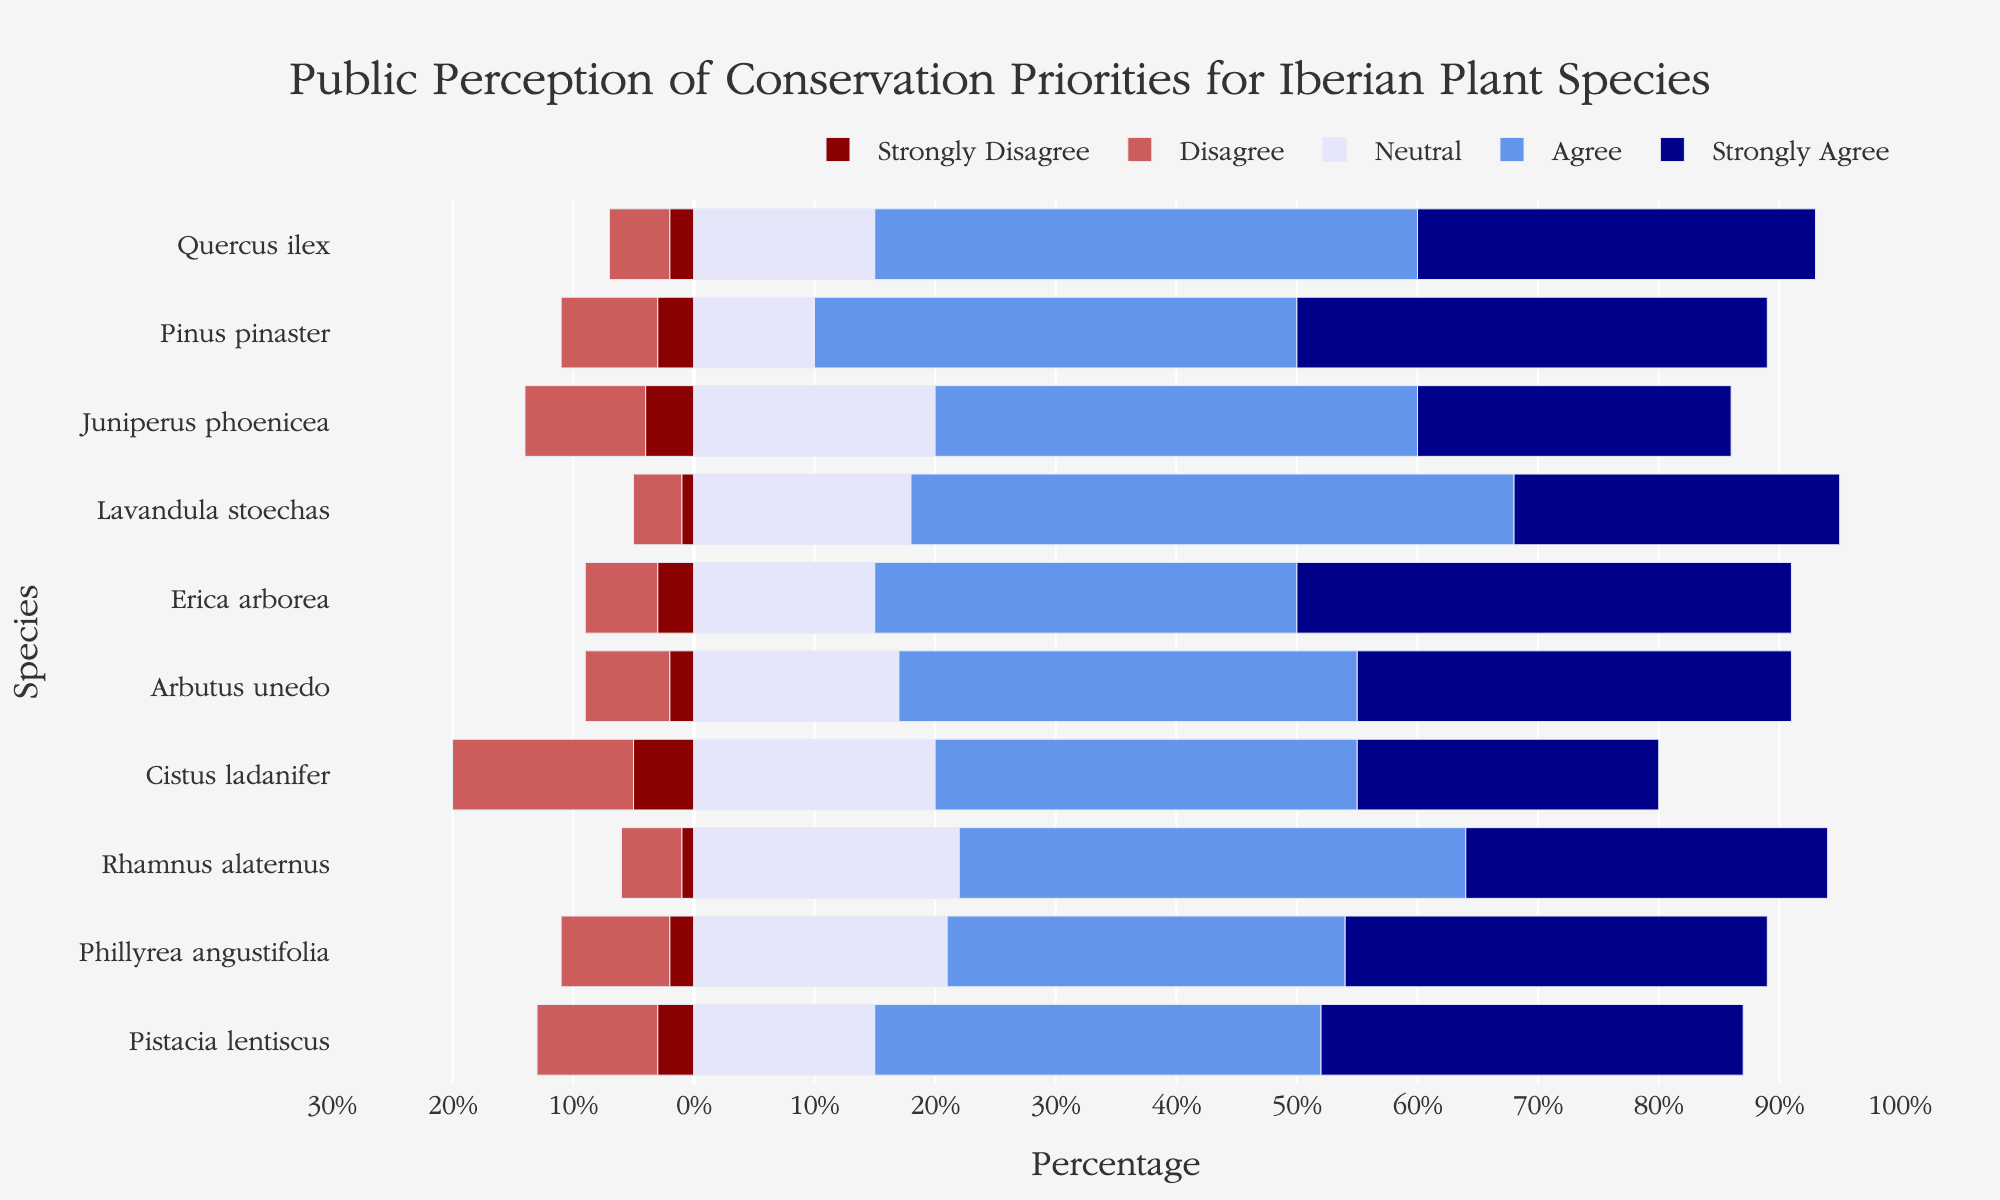What percentage of respondents agree or strongly agree with conserving Erica arborea? Sum the percentages of "Agree" and "Strongly Agree" for Erica arborea: 35% (Agree) + 41% (Strongly Agree) = 76%.
Answer: 76% Which species has the highest percentage of "Neutral" responses? Look at the "Neutral" category for each species and identify the one with the highest percentage. Phillyrea angustifolia has 21%, which is the highest among all species.
Answer: Phillyrea angustifolia Compare the percentage of "Agree" responses for Quercus ilex and Pinus pinaster. Which has more? Quercus ilex has 45% "Agree" responses, while Pinus pinaster has 40%. Compare 45% and 40%.
Answer: Quercus ilex Which species has the lowest percentage of "Strongly Disagree" responses? Look at the "Strongly Disagree" category and find the species with the lowest value. Lavandula stoechas has the lowest at 1%.
Answer: Lavandula stoechas What is the total percentage of positive responses ("Agree" and "Strongly Agree") for Pinus pinaster and Arbutus unedo combined? Sum the "Agree" and "Strongly Agree" percentages for both species: Pinus pinaster (40% + 39%) + Arbutus unedo (38% + 36%) = 79% + 74% = 153%.
Answer: 153% How does the percentage of "Disagree" responses for Juniperus phoenicea compare to that of Cistus ladanifer? Juniperus phoenicea has 10% "Disagree" responses, while Cistus ladanifer has 15%. Compare 10% and 15%.
Answer: Juniperus phoenicea What is the difference in percentage points between the "Strongly Agree" responses for Cistus ladanifer and Pinus pinaster? Subtract the "Strongly Agree" percentage of Cistus ladanifer from that of Pinus pinaster: 39% (Pinus pinaster) - 25% (Cistus ladanifer) = 14 percentage points.
Answer: 14 percentage points Which species has the most evenly distributed opinions across all categories? The species with values closest together across all five categories is Cistus ladanifer: 5%, 15%, 20%, 35%, 25%.
Answer: Cistus ladanifer How many species have at least 30% "Strongly Agree" responses? Identify species with "Strongly Agree" percentages of 30% or more: Quercus ilex (33%), Pinus pinaster (39%), Erica arborea (41%), and Phillyrea angustifolia (35%).
Answer: 4 